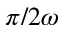<formula> <loc_0><loc_0><loc_500><loc_500>\pi / 2 \omega</formula> 